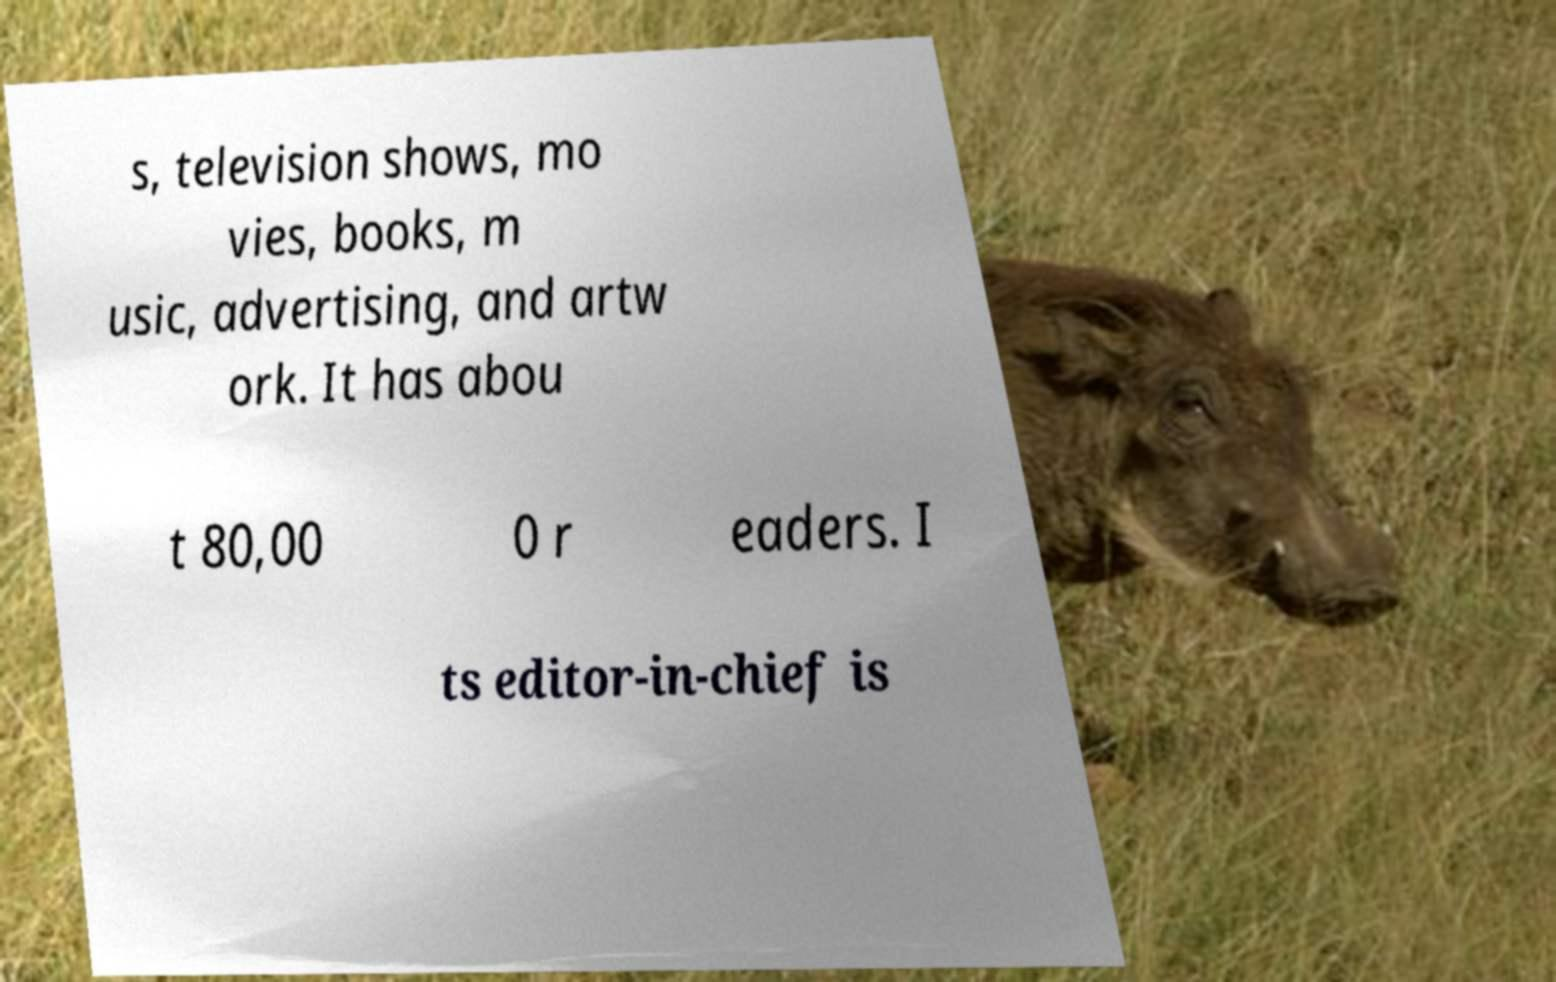Can you read and provide the text displayed in the image?This photo seems to have some interesting text. Can you extract and type it out for me? s, television shows, mo vies, books, m usic, advertising, and artw ork. It has abou t 80,00 0 r eaders. I ts editor-in-chief is 